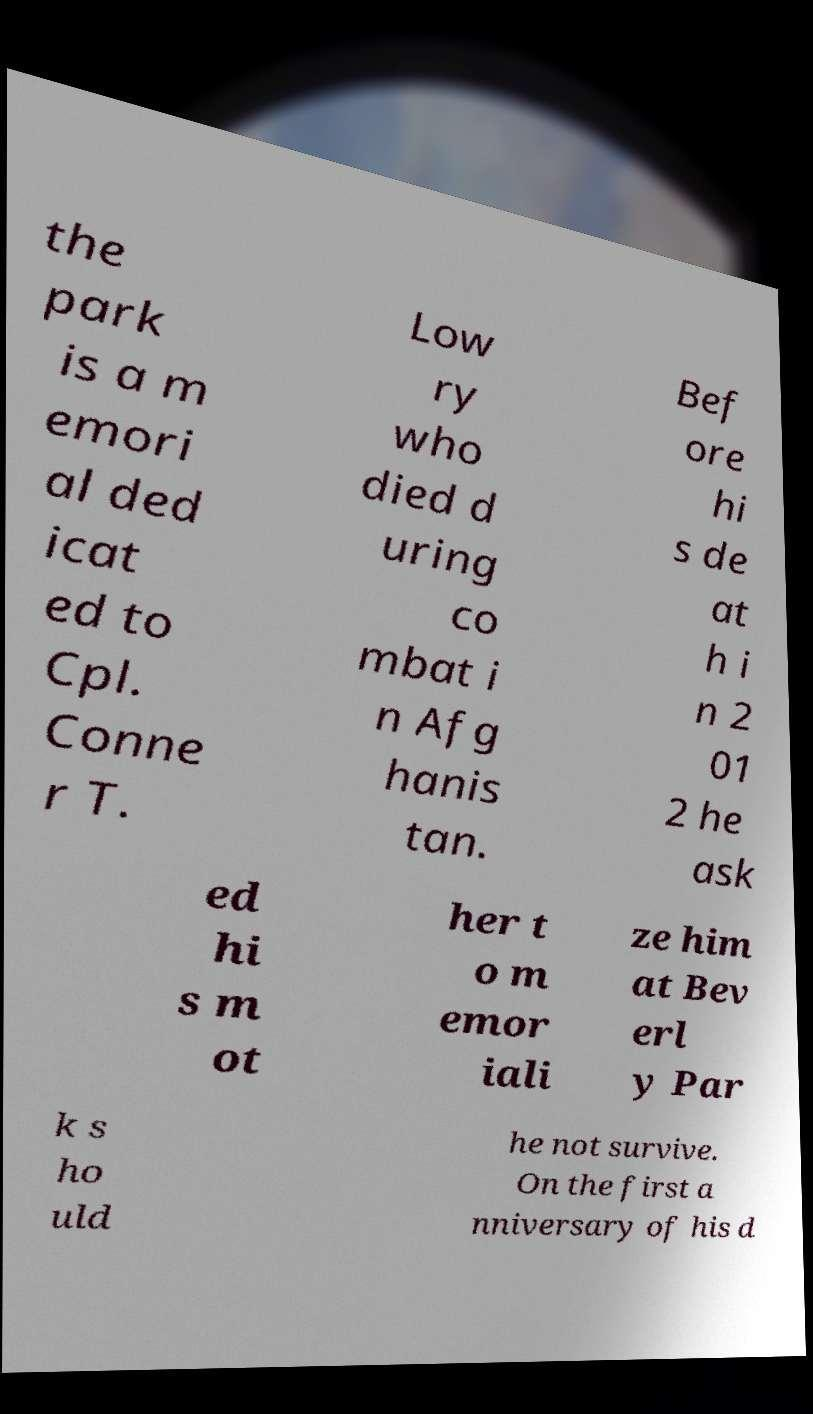Please read and relay the text visible in this image. What does it say? the park is a m emori al ded icat ed to Cpl. Conne r T. Low ry who died d uring co mbat i n Afg hanis tan. Bef ore hi s de at h i n 2 01 2 he ask ed hi s m ot her t o m emor iali ze him at Bev erl y Par k s ho uld he not survive. On the first a nniversary of his d 